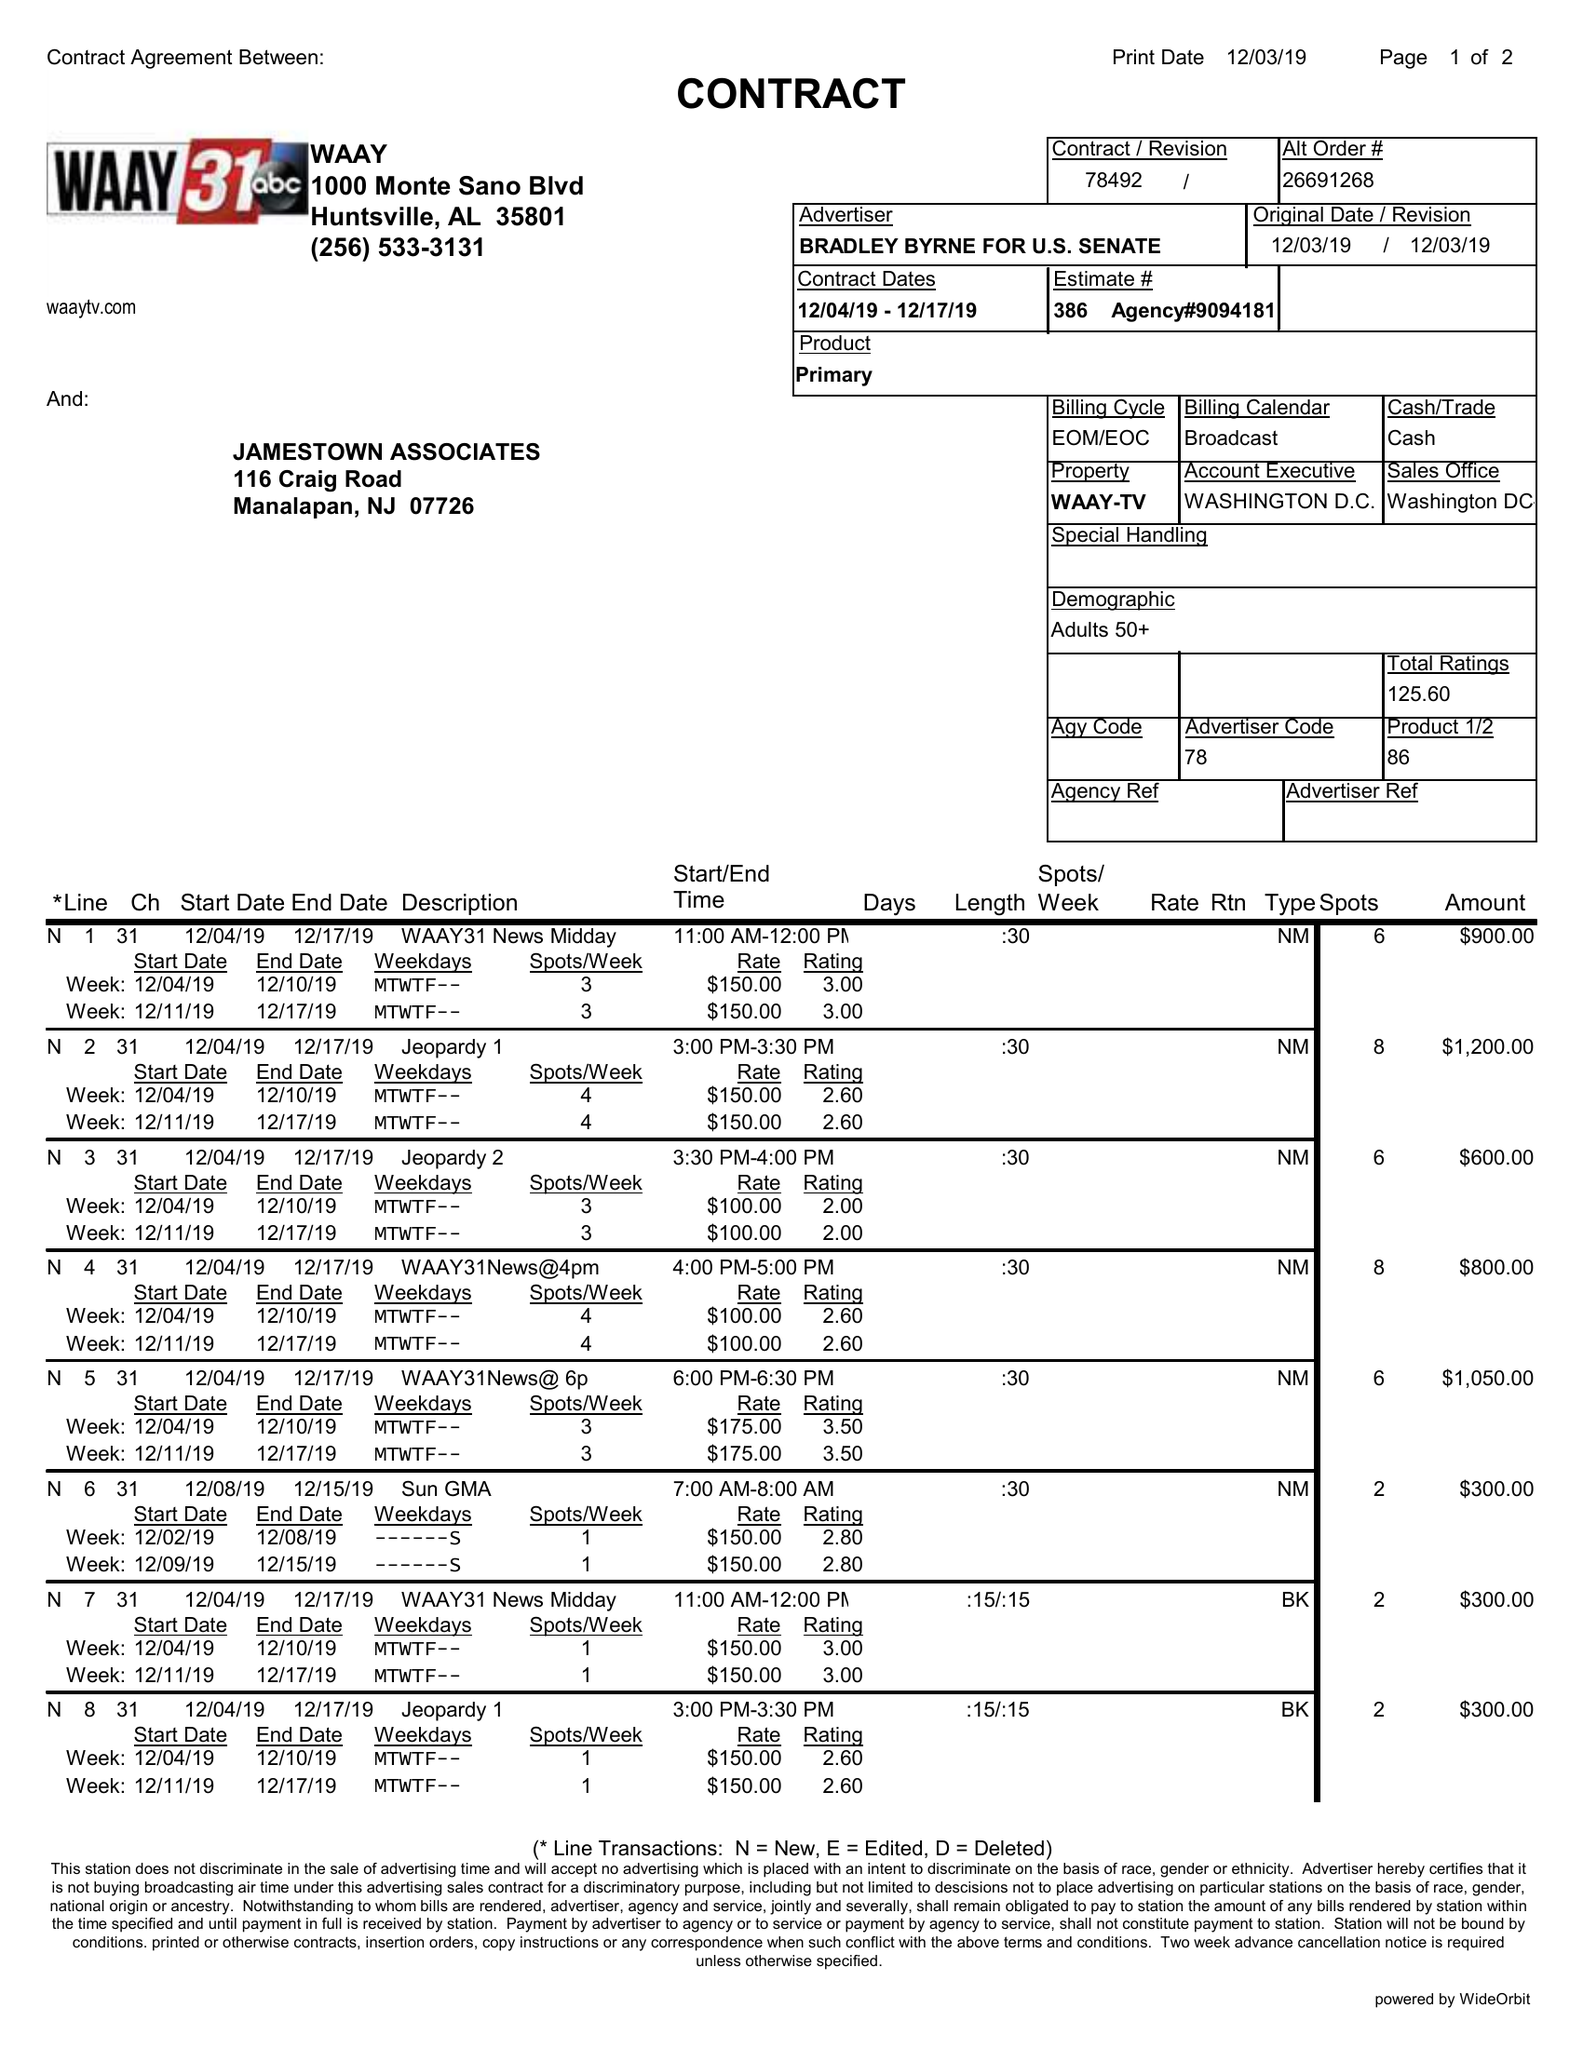What is the value for the advertiser?
Answer the question using a single word or phrase. BRADLEY BYRNE FOR U.S. SENATE 